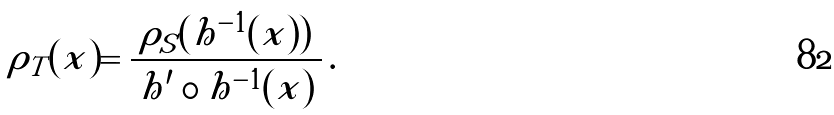<formula> <loc_0><loc_0><loc_500><loc_500>\rho _ { T } ( x ) = \frac { \rho _ { S } ( h ^ { - 1 } ( x ) ) } { \left | h ^ { \prime } \circ h ^ { - 1 } ( x ) \right | } \, .</formula> 